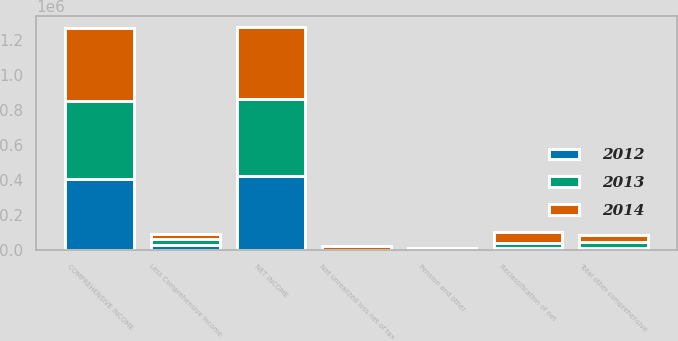Convert chart to OTSL. <chart><loc_0><loc_0><loc_500><loc_500><stacked_bar_chart><ecel><fcel>NET INCOME<fcel>Net unrealized loss net of tax<fcel>Reclassification of net<fcel>Pension and other<fcel>Total other comprehensive<fcel>COMPREHENSIVE INCOME<fcel>Less Comprehensive income<nl><fcel>2012<fcel>423696<fcel>810<fcel>13483<fcel>2761<fcel>9912<fcel>407507<fcel>26101<nl><fcel>2013<fcel>439966<fcel>213<fcel>26747<fcel>9421<fcel>35955<fcel>442029<fcel>33892<nl><fcel>2014<fcel>413164<fcel>22763<fcel>59887<fcel>1031<fcel>38155<fcel>419697<fcel>31622<nl></chart> 